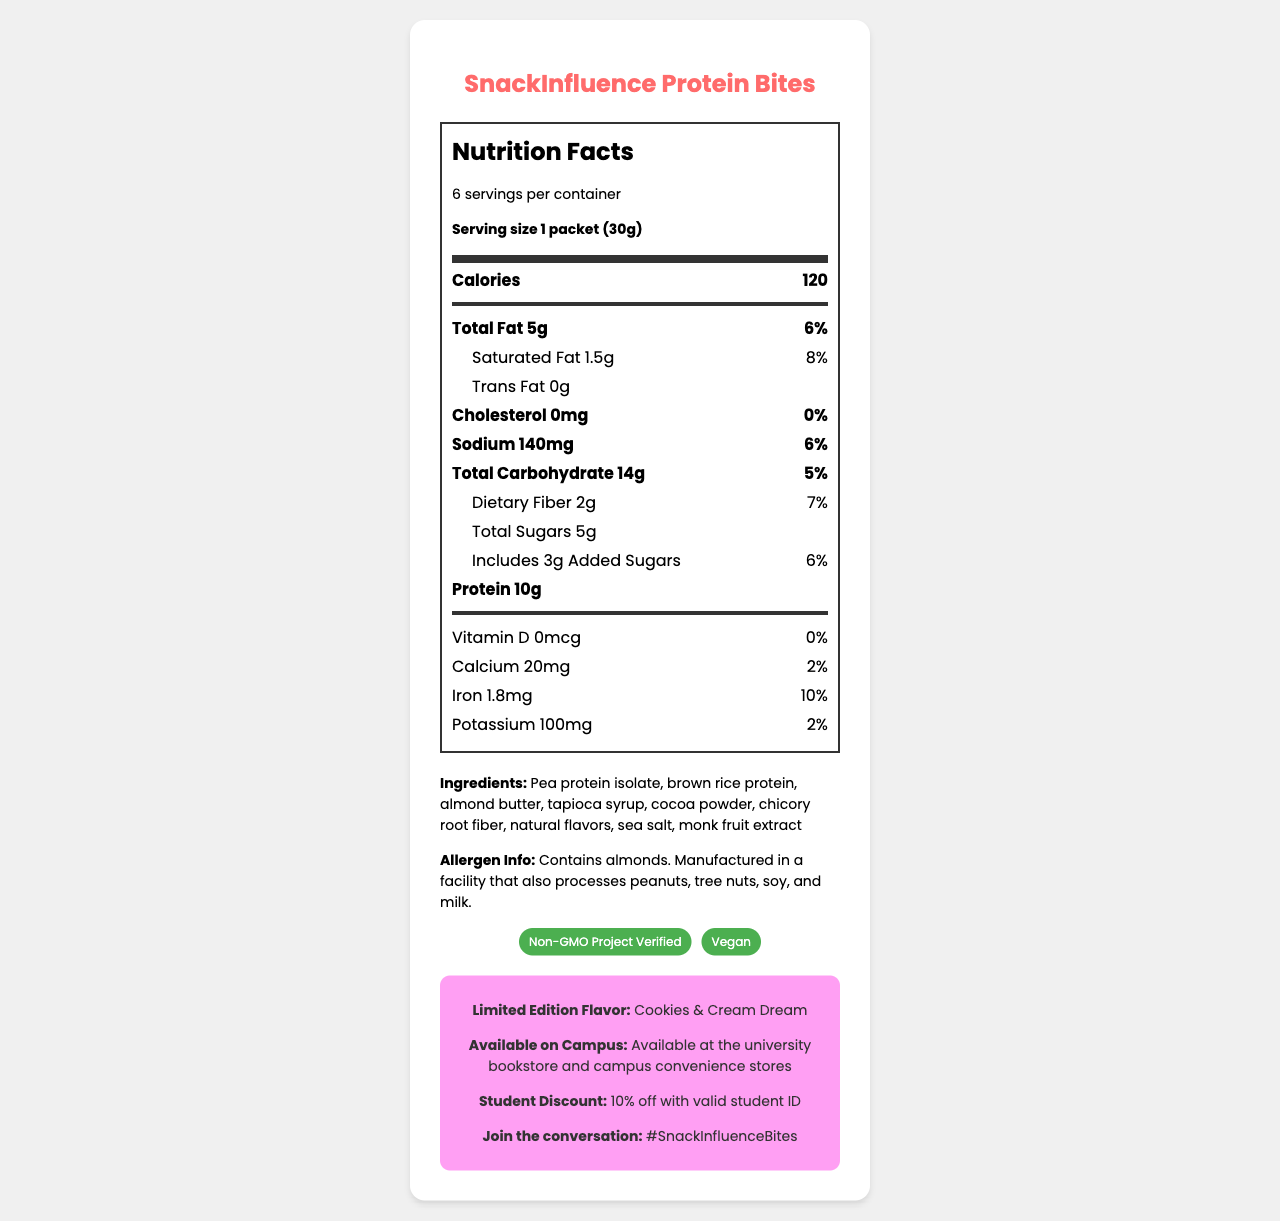what is the serving size? The serving size is explicitly stated as "1 packet (30g)" in the Nutrition Facts section.
Answer: 1 packet (30g) How many calories are in one serving? The document specifies that one serving contains 120 calories under the Calories section.
Answer: 120 List the ingredients in the SnackInfluence Protein Bites. The ingredients are listed in the Ingredients section of the document.
Answer: Pea protein isolate, brown rice protein, almond butter, tapioca syrup, cocoa powder, chicory root fiber, natural flavors, sea salt, monk fruit extract How much sodium is in one serving and what is the daily value percentage? The sodium amount is 140mg per serving, with a daily value percentage of 6%.
Answer: 140mg, 6% What certifications does the product have? The certifications section lists "Non-GMO Project Verified" and "Vegan."
Answer: Non-GMO Project Verified, Vegan How many servings are there per container? The document mentions that there are 6 servings per container in the Nutrition Facts section.
Answer: 6 How much protein is in one serving? The protein amount per serving is listed as 10g in the document.
Answer: 10g Does the product contain any allergens? The allergen information section states that it contains almonds and is manufactured in a facility that also processes other common allergens.
Answer: Yes, it contains almonds and is manufactured in a facility that also processes peanuts, tree nuts, soy, and milk. What is the limited edition flavor of the SnackInfluence Protein Bites? The limited edition flavor is identified as "Cookies & Cream Dream" in the influencer info section.
Answer: Cookies & Cream Dream When referring to the Nutrition Facts, which nutrient has the highest daily value percentage? 
A. Saturated Fat
B. Dietary Fiber
C. Iron
D. Sodium Saturated Fat has 8%, Dietary Fiber has 7%, Iron has 10%, and Sodium has 6%. Iron has the highest daily value percentage.
Answer: C. Iron Where can you purchase the SnackInfluence Protein Bites on campus?
A. University cafeteria
B. University bookstore and campus convenience stores
C. Campus gym
D. Library café The document specifies that the product is available at the university bookstore and campus convenience stores.
Answer: B. University bookstore and campus convenience stores Does the product contain any trans fat? The document specifies that the trans fat content is 0g.
Answer: No Summarize the main nutritional highlights and extras about the SnackInfluence Protein Bites. This summary encapsulates the key nutritional facts, allergen information, available certifications, and additional product highlights provided in the document.
Answer: The SnackInfluence Protein Bites provide 120 calories per serving with 10g of protein. Each serving contains 5g of total fat, 1.5g of saturated fat, and 0g of trans fat. It also contains 140mg of sodium, 14g of carbohydrates, 2g of dietary fiber, and 5g of sugars, including 3g of added sugars. The product is vegan, non-GMO, contains almonds, and has a limited edition Cookies & Cream Dream flavor available on campus with a 10% student discount. What are the health benefits of monk fruit extract? The document lists monk fruit extract as an ingredient but does not provide information on its health benefits.
Answer: Cannot be determined 